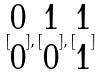Convert formula to latex. <formula><loc_0><loc_0><loc_500><loc_500>[ \begin{matrix} 0 \\ 0 \end{matrix} ] , [ \begin{matrix} 1 \\ 0 \end{matrix} ] , [ \begin{matrix} 1 \\ 1 \end{matrix} ]</formula> 